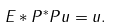Convert formula to latex. <formula><loc_0><loc_0><loc_500><loc_500>E * P ^ { * } P u = u .</formula> 